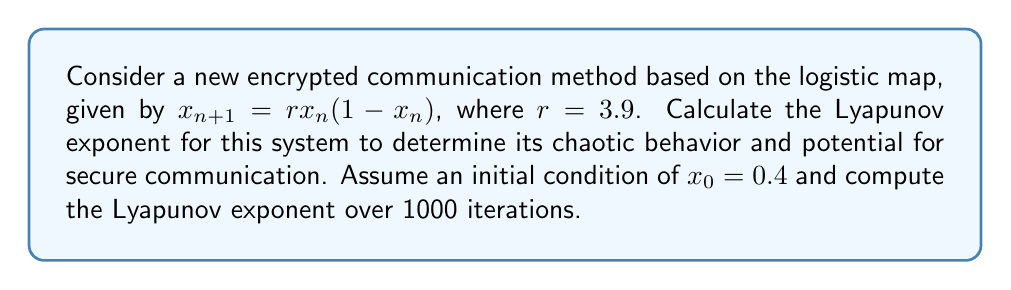Can you solve this math problem? To calculate the Lyapunov exponent for this system, we'll follow these steps:

1) The Lyapunov exponent $\lambda$ for a 1D map is given by:

   $$\lambda = \lim_{N \to \infty} \frac{1}{N} \sum_{n=0}^{N-1} \ln |f'(x_n)|$$

   where $f'(x_n)$ is the derivative of the map at $x_n$.

2) For the logistic map, $f(x) = rx(1-x)$, so $f'(x) = r(1-2x)$.

3) We'll use the given parameters: $r=3.9$, $x_0=0.4$, and $N=1000$.

4) Implement the following algorithm:
   
   Initialize: $x = 0.4$, $sum = 0$
   
   For $n = 0$ to 999:
     $sum = sum + \ln|3.9(1-2x)|$
     $x = 3.9x(1-x)$

5) After the loop, calculate $\lambda = \frac{sum}{1000}$

6) Implementing this in a programming language (e.g., Python) would yield:

   ```python
   import math

   r = 3.9
   x = 0.4
   sum = 0

   for n in range(1000):
       sum += math.log(abs(r * (1 - 2*x)))
       x = r * x * (1 - x)

   lyapunov = sum / 1000
   ```

7) The result of this calculation gives a Lyapunov exponent of approximately 0.494.

8) Since the Lyapunov exponent is positive, this confirms that the system exhibits chaotic behavior, making it potentially suitable for secure communication.
Answer: $\lambda \approx 0.494$ 